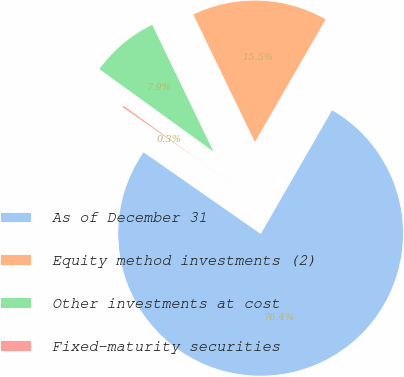Convert chart. <chart><loc_0><loc_0><loc_500><loc_500><pie_chart><fcel>As of December 31<fcel>Equity method investments (2)<fcel>Other investments at cost<fcel>Fixed-maturity securities<nl><fcel>76.37%<fcel>15.49%<fcel>7.88%<fcel>0.27%<nl></chart> 